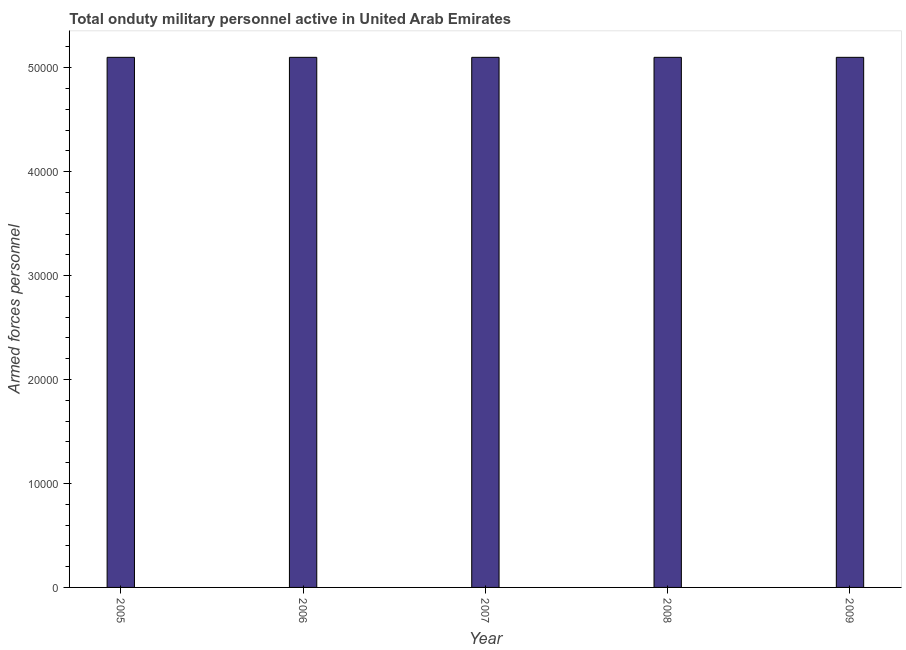What is the title of the graph?
Give a very brief answer. Total onduty military personnel active in United Arab Emirates. What is the label or title of the X-axis?
Your answer should be very brief. Year. What is the label or title of the Y-axis?
Offer a terse response. Armed forces personnel. What is the number of armed forces personnel in 2008?
Keep it short and to the point. 5.10e+04. Across all years, what is the maximum number of armed forces personnel?
Your response must be concise. 5.10e+04. Across all years, what is the minimum number of armed forces personnel?
Your answer should be very brief. 5.10e+04. What is the sum of the number of armed forces personnel?
Ensure brevity in your answer.  2.55e+05. What is the average number of armed forces personnel per year?
Offer a terse response. 5.10e+04. What is the median number of armed forces personnel?
Make the answer very short. 5.10e+04. In how many years, is the number of armed forces personnel greater than 16000 ?
Provide a succinct answer. 5. Do a majority of the years between 2007 and 2005 (inclusive) have number of armed forces personnel greater than 32000 ?
Your answer should be compact. Yes. Is the number of armed forces personnel in 2006 less than that in 2009?
Ensure brevity in your answer.  No. What is the difference between the highest and the second highest number of armed forces personnel?
Your response must be concise. 0. Is the sum of the number of armed forces personnel in 2005 and 2008 greater than the maximum number of armed forces personnel across all years?
Make the answer very short. Yes. What is the difference between the highest and the lowest number of armed forces personnel?
Your answer should be very brief. 0. How many bars are there?
Your response must be concise. 5. Are all the bars in the graph horizontal?
Your answer should be very brief. No. How many years are there in the graph?
Your answer should be very brief. 5. Are the values on the major ticks of Y-axis written in scientific E-notation?
Give a very brief answer. No. What is the Armed forces personnel of 2005?
Offer a very short reply. 5.10e+04. What is the Armed forces personnel in 2006?
Give a very brief answer. 5.10e+04. What is the Armed forces personnel in 2007?
Your answer should be very brief. 5.10e+04. What is the Armed forces personnel in 2008?
Offer a terse response. 5.10e+04. What is the Armed forces personnel of 2009?
Offer a terse response. 5.10e+04. What is the difference between the Armed forces personnel in 2005 and 2006?
Make the answer very short. 0. What is the difference between the Armed forces personnel in 2005 and 2007?
Offer a terse response. 0. What is the difference between the Armed forces personnel in 2005 and 2008?
Your answer should be very brief. 0. What is the difference between the Armed forces personnel in 2005 and 2009?
Provide a succinct answer. 0. What is the difference between the Armed forces personnel in 2006 and 2008?
Offer a very short reply. 0. What is the difference between the Armed forces personnel in 2007 and 2008?
Provide a short and direct response. 0. What is the difference between the Armed forces personnel in 2007 and 2009?
Provide a succinct answer. 0. What is the difference between the Armed forces personnel in 2008 and 2009?
Provide a short and direct response. 0. What is the ratio of the Armed forces personnel in 2005 to that in 2006?
Your answer should be very brief. 1. What is the ratio of the Armed forces personnel in 2006 to that in 2009?
Give a very brief answer. 1. What is the ratio of the Armed forces personnel in 2007 to that in 2008?
Your answer should be compact. 1. What is the ratio of the Armed forces personnel in 2007 to that in 2009?
Keep it short and to the point. 1. What is the ratio of the Armed forces personnel in 2008 to that in 2009?
Provide a short and direct response. 1. 